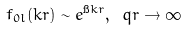Convert formula to latex. <formula><loc_0><loc_0><loc_500><loc_500>f _ { 0 l } ( k r ) \sim e ^ { \i k r } , \ q r \rightarrow \infty</formula> 